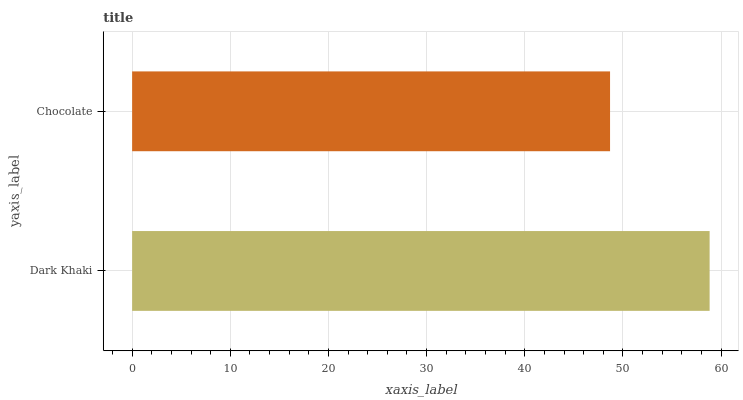Is Chocolate the minimum?
Answer yes or no. Yes. Is Dark Khaki the maximum?
Answer yes or no. Yes. Is Chocolate the maximum?
Answer yes or no. No. Is Dark Khaki greater than Chocolate?
Answer yes or no. Yes. Is Chocolate less than Dark Khaki?
Answer yes or no. Yes. Is Chocolate greater than Dark Khaki?
Answer yes or no. No. Is Dark Khaki less than Chocolate?
Answer yes or no. No. Is Dark Khaki the high median?
Answer yes or no. Yes. Is Chocolate the low median?
Answer yes or no. Yes. Is Chocolate the high median?
Answer yes or no. No. Is Dark Khaki the low median?
Answer yes or no. No. 